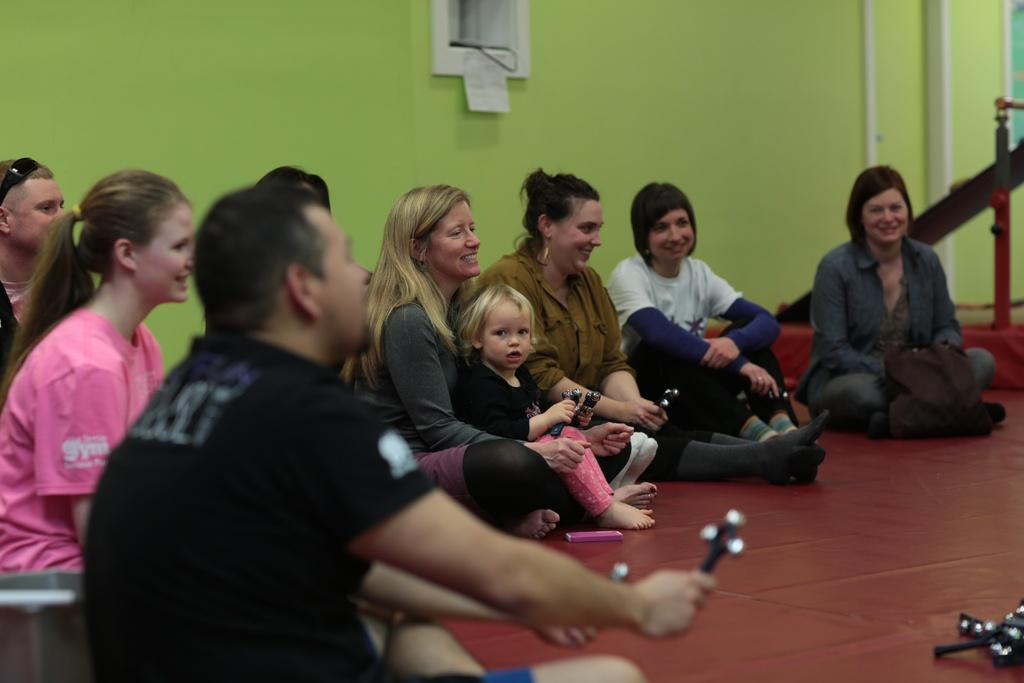What is the main subject of the image? The main subject of the image is a group of people. What can be seen in the background of the image? There is a wall in the background of the image. What is located on the left side of the image? There are metal rods on the left side of the image. What type of paper is being used to support the theory in the image? There is no paper or theory present in the image; it features a group of people, a wall, and metal rods. 